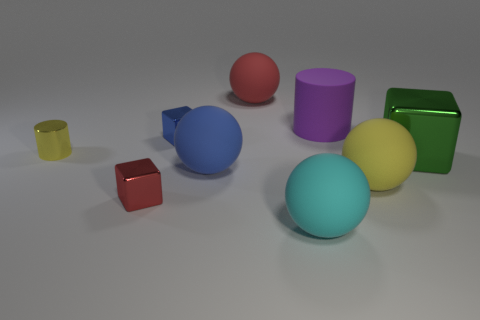Subtract 1 spheres. How many spheres are left? 3 Add 1 small cyan rubber cylinders. How many objects exist? 10 Subtract all blocks. How many objects are left? 6 Subtract all blue rubber balls. Subtract all cyan metallic balls. How many objects are left? 8 Add 7 small shiny things. How many small shiny things are left? 10 Add 6 yellow matte balls. How many yellow matte balls exist? 7 Subtract 0 brown cubes. How many objects are left? 9 